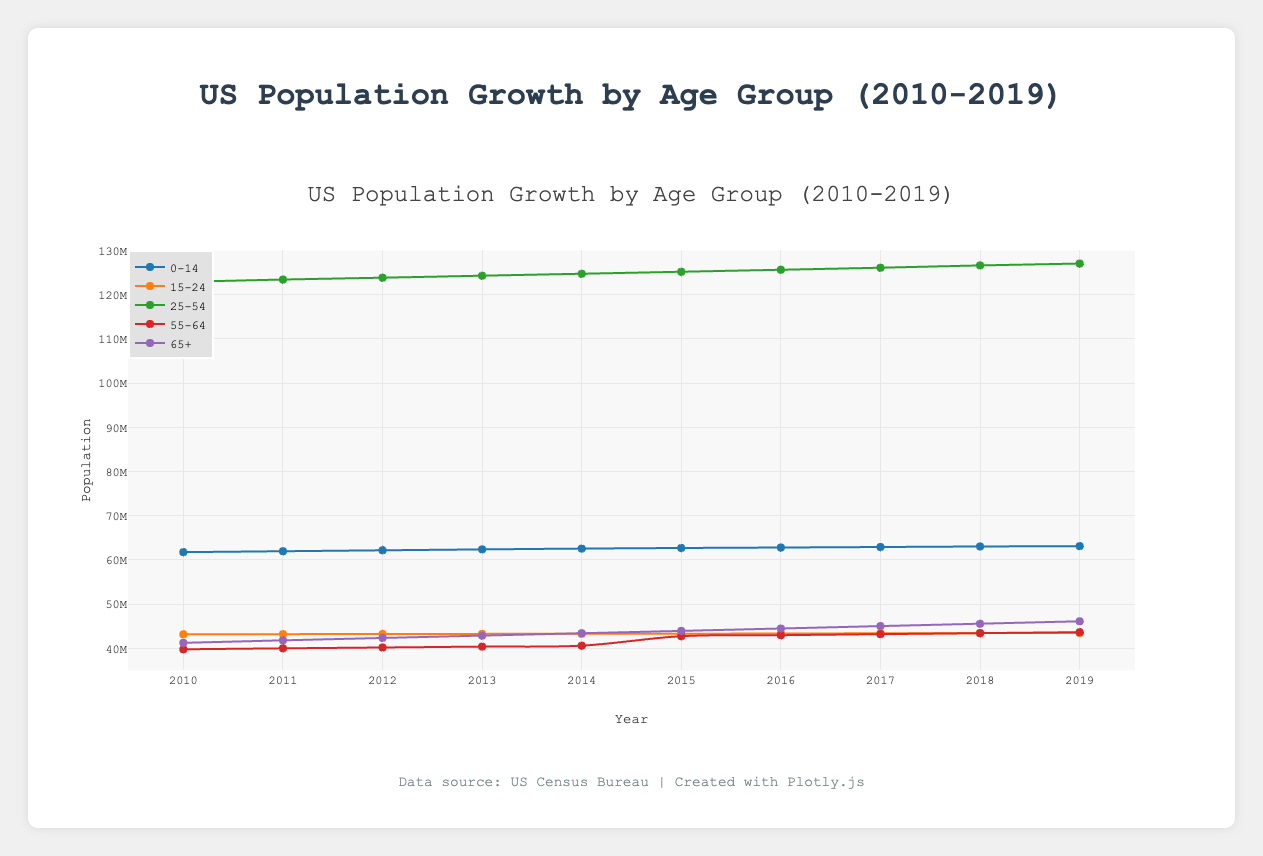**Question Explanation
Answer: Concise Answer** What is the title of the plot? The title is clearly visible at the top of the plot and is usually the first textual element that provides context to the figure.
Answer: US Population Growth by Age Group (2010-2019) How many age groups are represented in the plot? By counting the distinct lines or markers in the legend, which represent different age groups, we can determine the number of age groups.
Answer: 5 Which year is represented as the range on the x-axis? The x-axis typically represents the time period for the population data. The start and end points of the x-axis provide this information.
Answer: 2010 to 2019 What age group shows the highest overall population in 2019? By checking the y-axis values at the 2019 marker for each age group, we can see which one has the highest population.
Answer: 25-54 Which age group saw the most significant increase in population from 2010 to 2019? By observing the difference in the y-axis values for each age group between the years 2010 and 2019, we can identify the group with the largest increase.
Answer: 65+ What is the approximate population of the 0-14 age group in 2015? Locate the data point for the 0-14 age group in the year 2015 along the x-axis and refer to the corresponding y-axis value.
Answer: Approximately 62,712,678 Which age group had a relatively stable population during the period? By observing the slope of the lines or the spread of data points, the group with the least change can be identified.
Answer: 15-24 Is there any age group that never crossed the 50 million population mark throughout the decade? Evaluate each line and check if any of them remained below 50 million on the y-axis through all the years.
Answer: No Compare the population growth rate between the 55-64 and 65+ age groups. Which grew faster? Calculate the difference in population from 2010 to 2019 for both age groups and compare their growth rates.
Answer: 65+ What was the population difference between the 25-54 and 0-14 age groups in 2012? Find the population values for both groups in 2012 and subtract the 0-14 population from the 25-54 population.
Answer: Approximately 61,662,944 